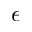<formula> <loc_0><loc_0><loc_500><loc_500>\epsilon</formula> 